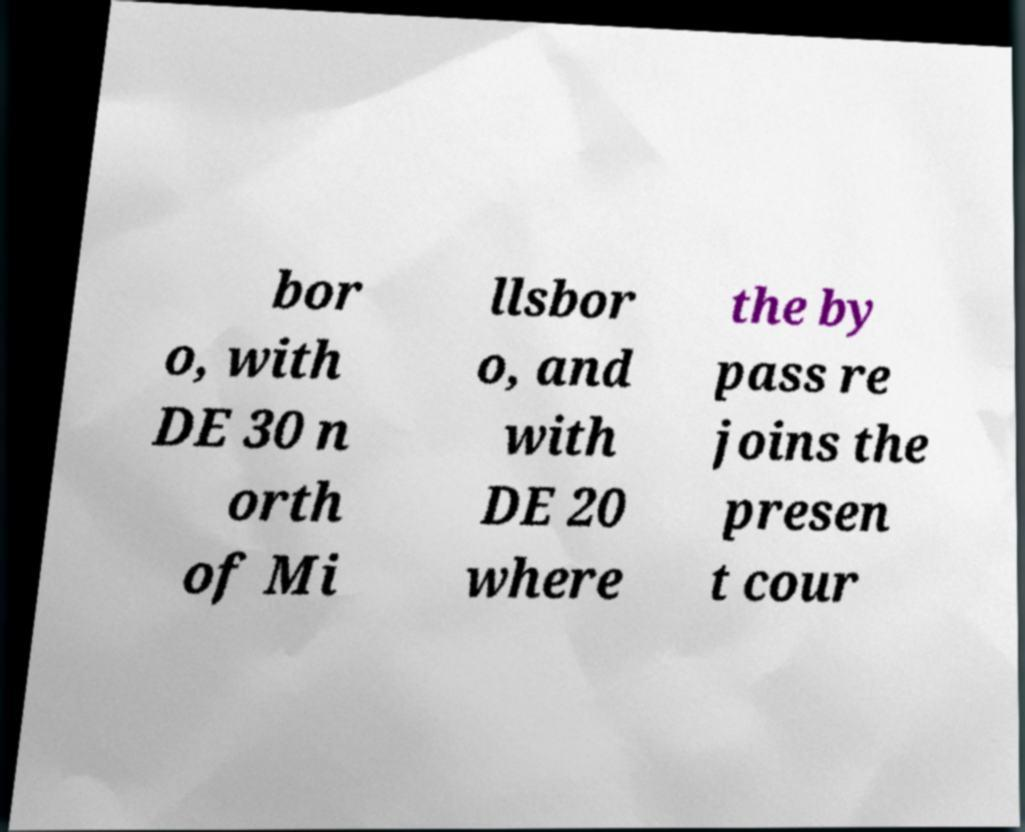Please read and relay the text visible in this image. What does it say? bor o, with DE 30 n orth of Mi llsbor o, and with DE 20 where the by pass re joins the presen t cour 